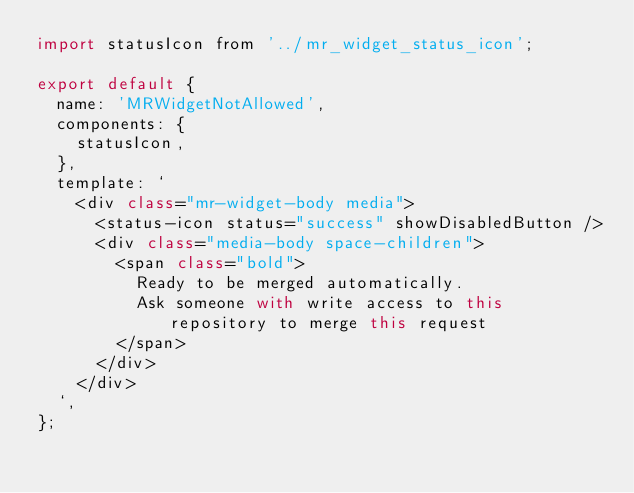<code> <loc_0><loc_0><loc_500><loc_500><_JavaScript_>import statusIcon from '../mr_widget_status_icon';

export default {
  name: 'MRWidgetNotAllowed',
  components: {
    statusIcon,
  },
  template: `
    <div class="mr-widget-body media">
      <status-icon status="success" showDisabledButton />
      <div class="media-body space-children">
        <span class="bold">
          Ready to be merged automatically.
          Ask someone with write access to this repository to merge this request
        </span>
      </div>
    </div>
  `,
};
</code> 